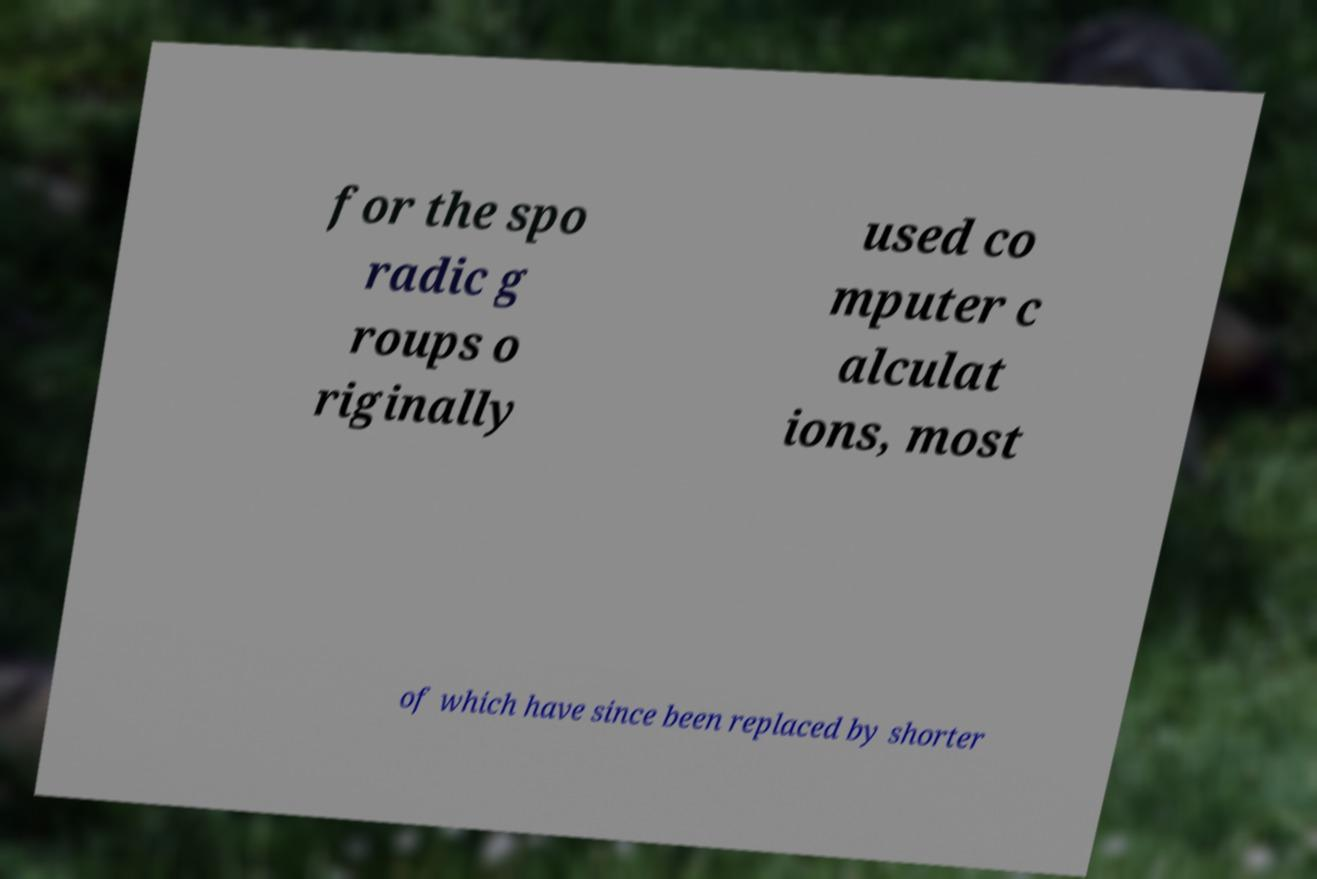I need the written content from this picture converted into text. Can you do that? for the spo radic g roups o riginally used co mputer c alculat ions, most of which have since been replaced by shorter 